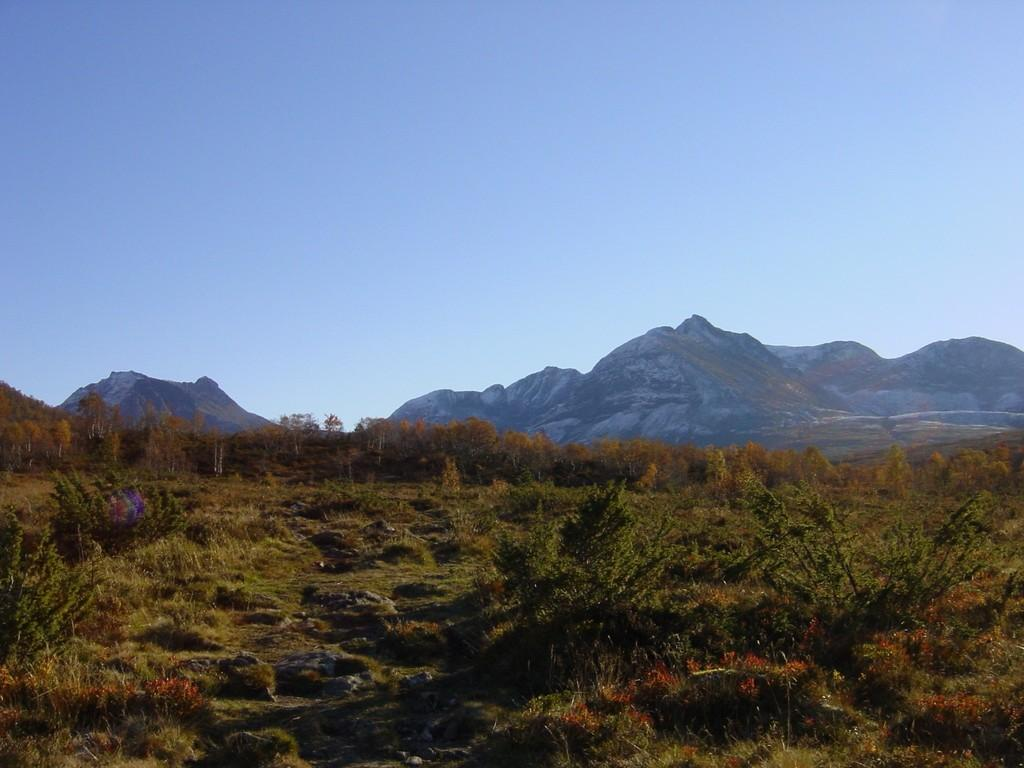What type of surface is visible in the image? There is a grass surface in the image. What can be seen growing on the grass surface? There are plants on the grass surface. What is visible in the background of the image? There are trees and hills visible in the background of the image. What part of the natural environment is visible in the image? The sky is visible in the background of the image. What type of jam is being used to glue the action figures together in the image? There are no action figures or jam present in the image. 